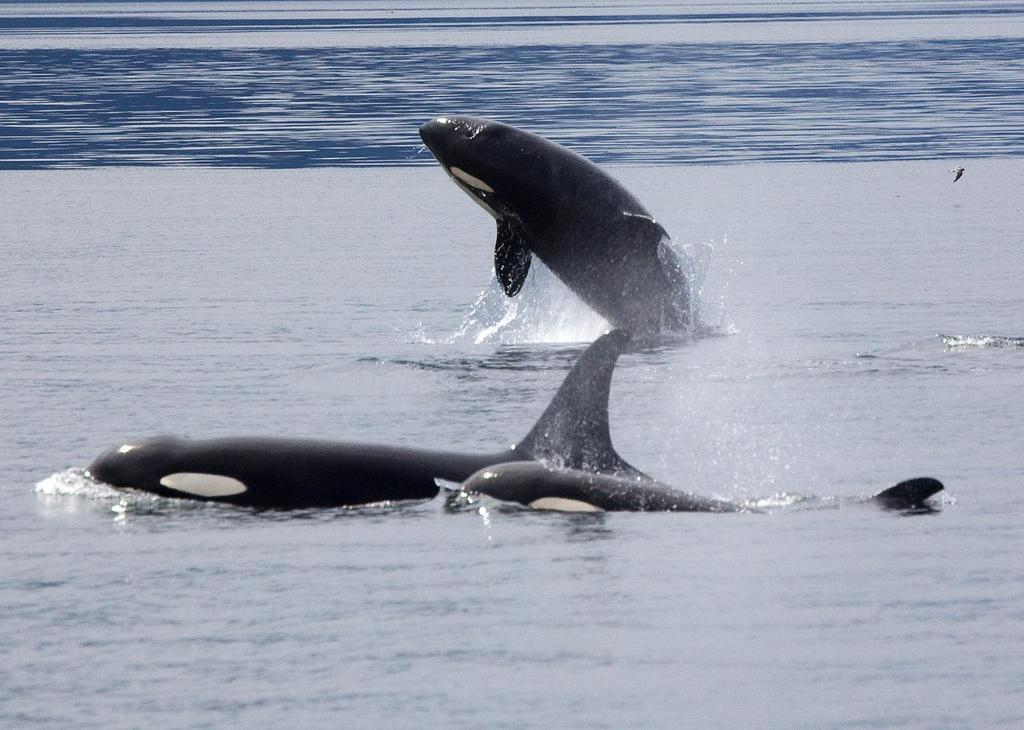How many dolphins are in the water in the image? There are three dolphins in the water in the image. What is one of the dolphins doing in the image? One of the dolphins is jumping out of the water in the image. What type of environment is depicted in the image? The image appears to depict a sea. Can you describe any other animals in the image? There is a tiny bird flying in the image. What type of hill can be seen in the background of the image? There is no hill visible in the image; it depicts a sea with dolphins and a bird. 